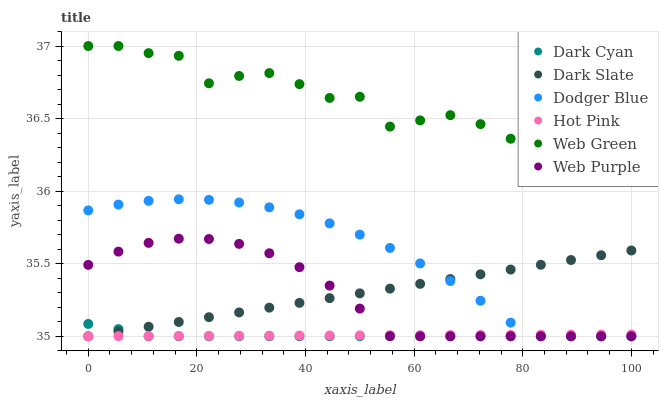Does Dark Cyan have the minimum area under the curve?
Answer yes or no. Yes. Does Web Green have the maximum area under the curve?
Answer yes or no. Yes. Does Dark Slate have the minimum area under the curve?
Answer yes or no. No. Does Dark Slate have the maximum area under the curve?
Answer yes or no. No. Is Dark Slate the smoothest?
Answer yes or no. Yes. Is Web Green the roughest?
Answer yes or no. Yes. Is Web Green the smoothest?
Answer yes or no. No. Is Dark Slate the roughest?
Answer yes or no. No. Does Hot Pink have the lowest value?
Answer yes or no. Yes. Does Web Green have the lowest value?
Answer yes or no. No. Does Web Green have the highest value?
Answer yes or no. Yes. Does Dark Slate have the highest value?
Answer yes or no. No. Is Dark Cyan less than Web Green?
Answer yes or no. Yes. Is Web Green greater than Web Purple?
Answer yes or no. Yes. Does Dark Slate intersect Web Purple?
Answer yes or no. Yes. Is Dark Slate less than Web Purple?
Answer yes or no. No. Is Dark Slate greater than Web Purple?
Answer yes or no. No. Does Dark Cyan intersect Web Green?
Answer yes or no. No. 